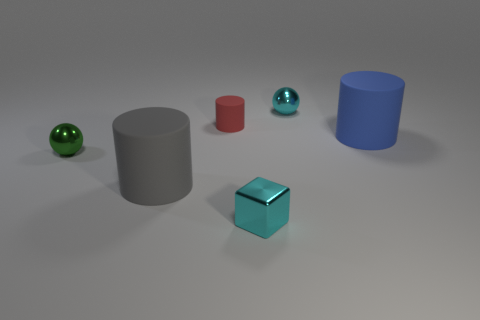Add 2 yellow metal cylinders. How many objects exist? 8 Subtract all gray rubber cylinders. How many cylinders are left? 2 Subtract 2 cylinders. How many cylinders are left? 1 Subtract all balls. How many objects are left? 4 Add 3 big blue matte objects. How many big blue matte objects are left? 4 Add 3 purple shiny cylinders. How many purple shiny cylinders exist? 3 Subtract 0 brown cylinders. How many objects are left? 6 Subtract all cyan cylinders. Subtract all blue blocks. How many cylinders are left? 3 Subtract all red objects. Subtract all blue rubber cylinders. How many objects are left? 4 